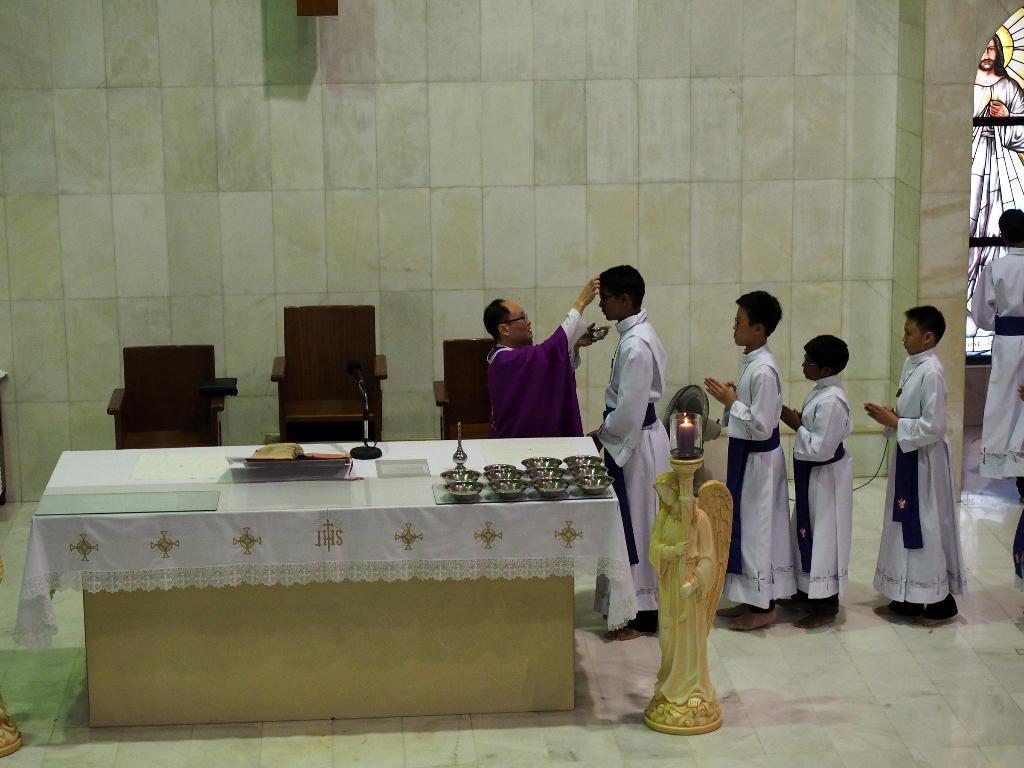Describe this image in one or two sentences. In this picture we can see the table with a cloth, bowls, mics and some objects on it and beside this table we can see a statue with a candle on it, chairs and some people standing on the floor and in the background we can see the wall and some objects. 